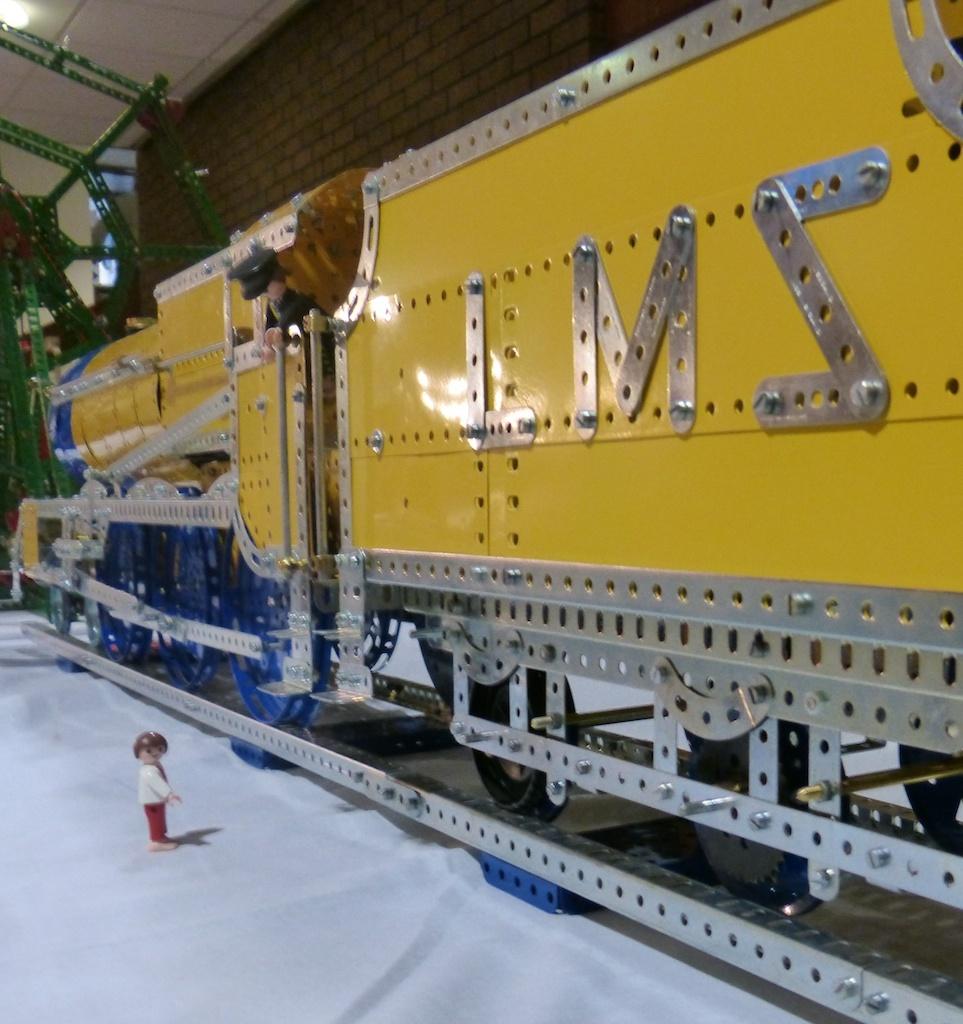What are the initials on the side of the train?
Keep it short and to the point. Lms. What is the last letter on the train?
Your response must be concise. S. 